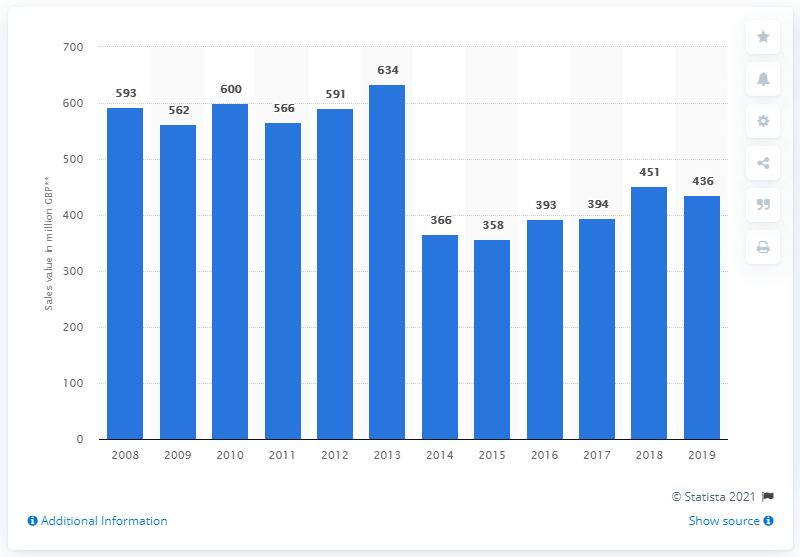Indicate a few pertinent items in this graphic. In 2018, the ice cream industry demonstrated a significant recovery. It is known that the sales from the manufacture of ice cream in the UK in 2019 were 436... 